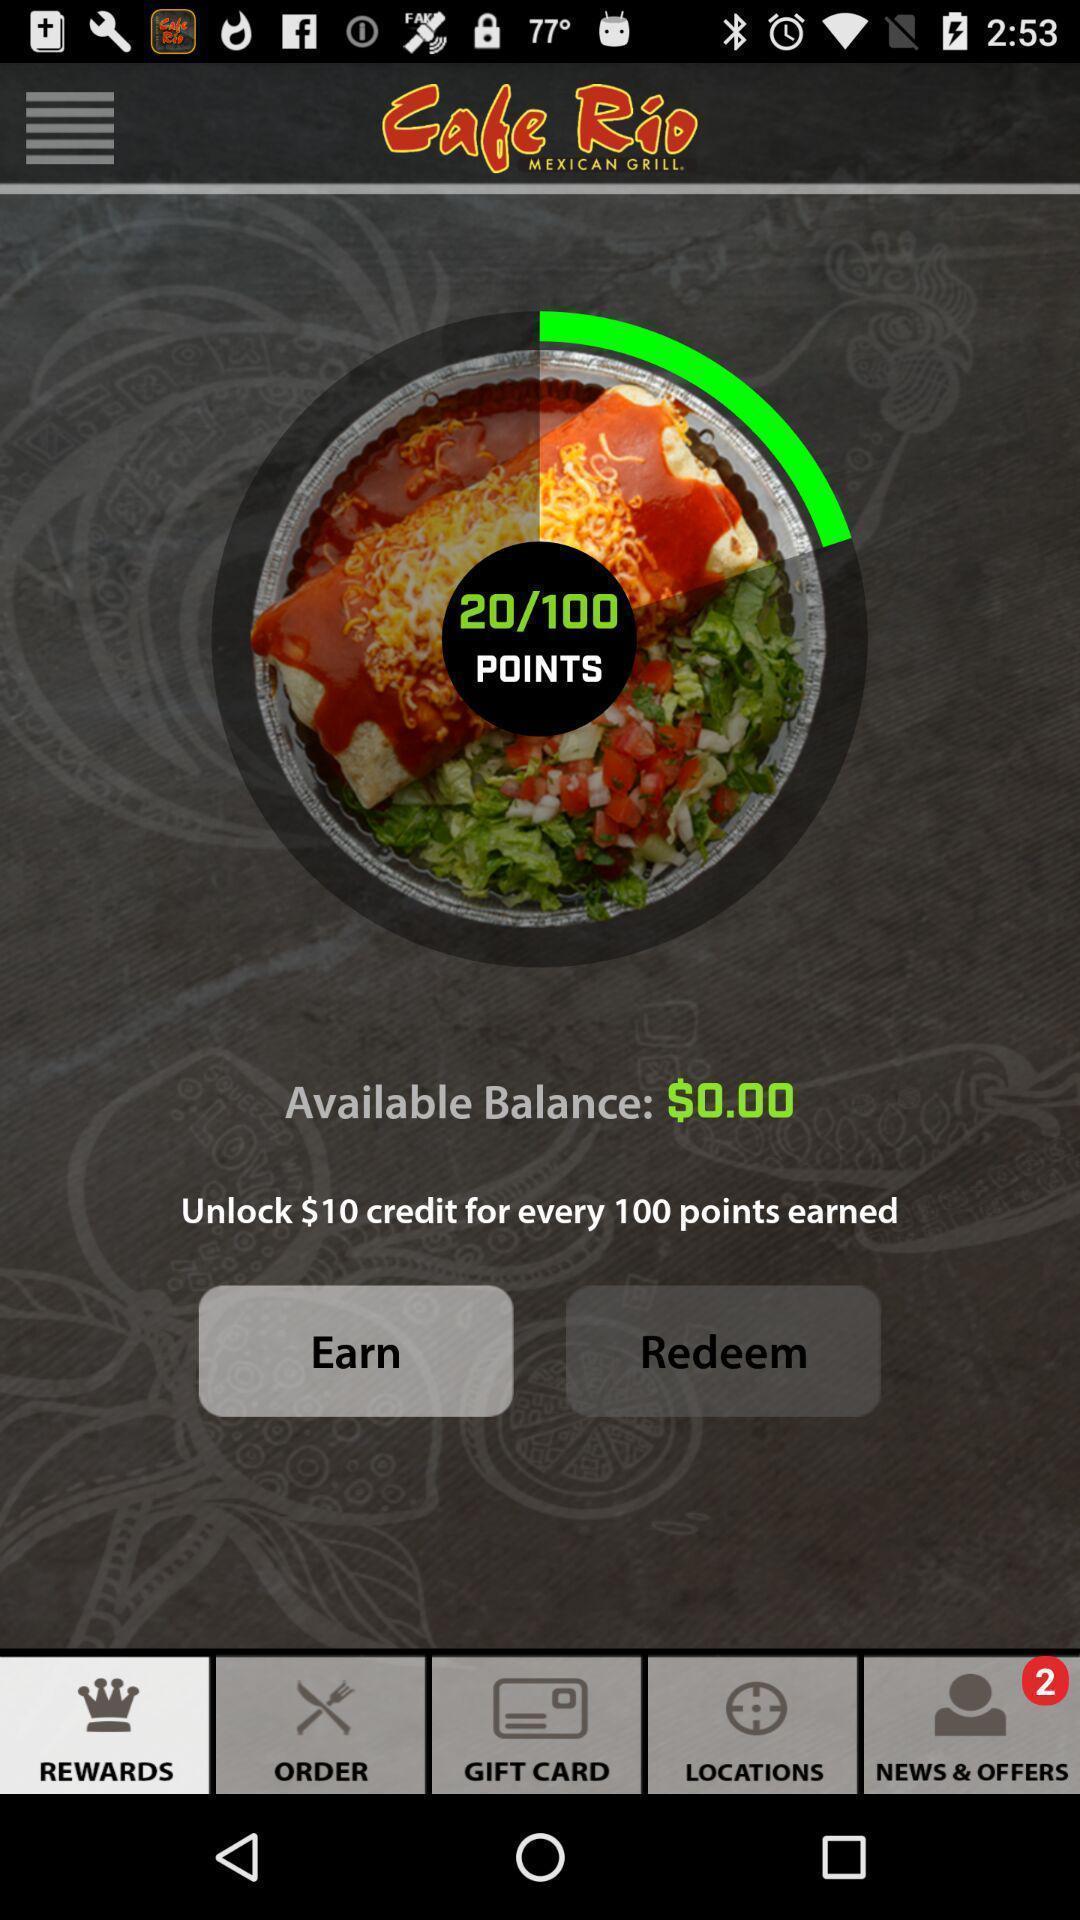Provide a textual representation of this image. Page showing balance in food app. 